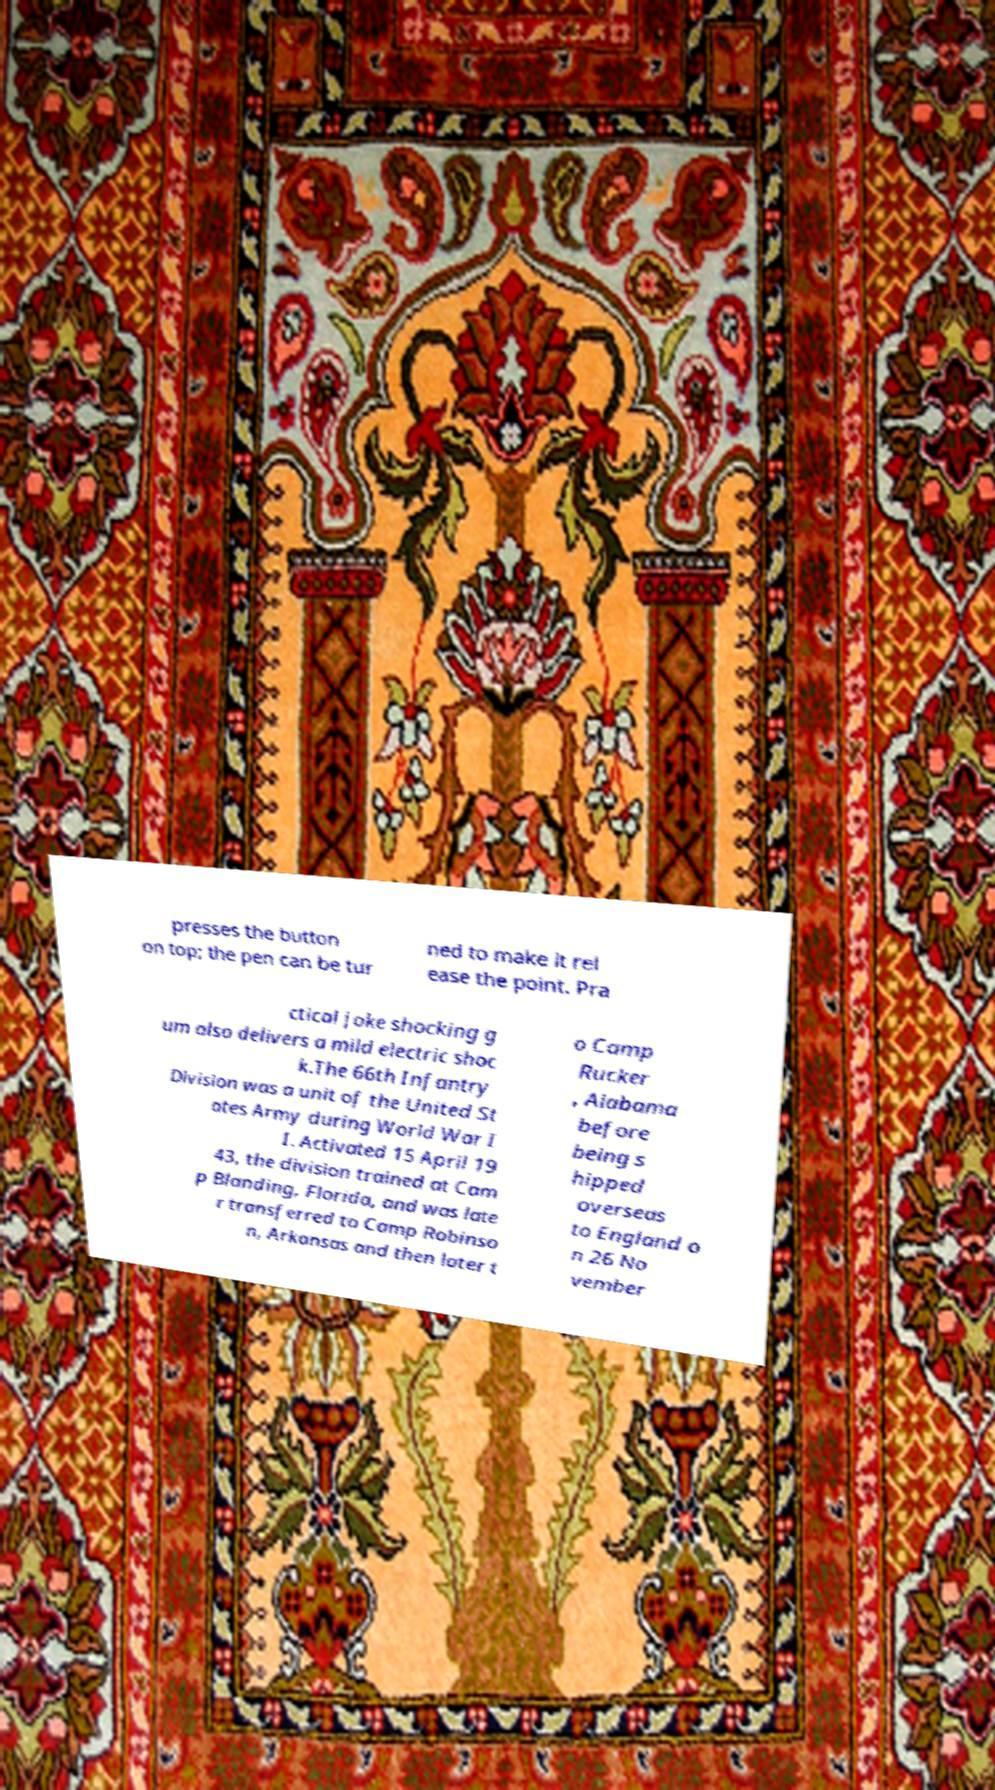Can you read and provide the text displayed in the image?This photo seems to have some interesting text. Can you extract and type it out for me? presses the button on top; the pen can be tur ned to make it rel ease the point. Pra ctical joke shocking g um also delivers a mild electric shoc k.The 66th Infantry Division was a unit of the United St ates Army during World War I I. Activated 15 April 19 43, the division trained at Cam p Blanding, Florida, and was late r transferred to Camp Robinso n, Arkansas and then later t o Camp Rucker , Alabama before being s hipped overseas to England o n 26 No vember 